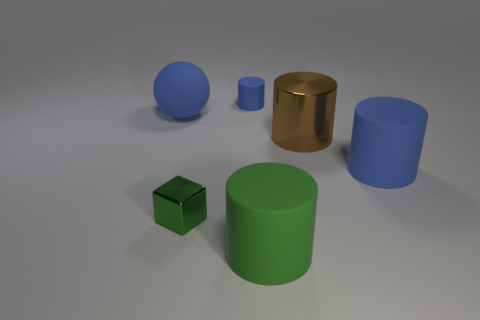Add 2 tiny green metal blocks. How many objects exist? 8 Subtract all large blue matte cylinders. How many cylinders are left? 3 Subtract all green cylinders. How many cylinders are left? 3 Add 5 large matte objects. How many large matte objects are left? 8 Add 6 green shiny blocks. How many green shiny blocks exist? 7 Subtract 0 purple cylinders. How many objects are left? 6 Subtract all spheres. How many objects are left? 5 Subtract 1 cubes. How many cubes are left? 0 Subtract all green cylinders. Subtract all yellow balls. How many cylinders are left? 3 Subtract all blue balls. How many brown cylinders are left? 1 